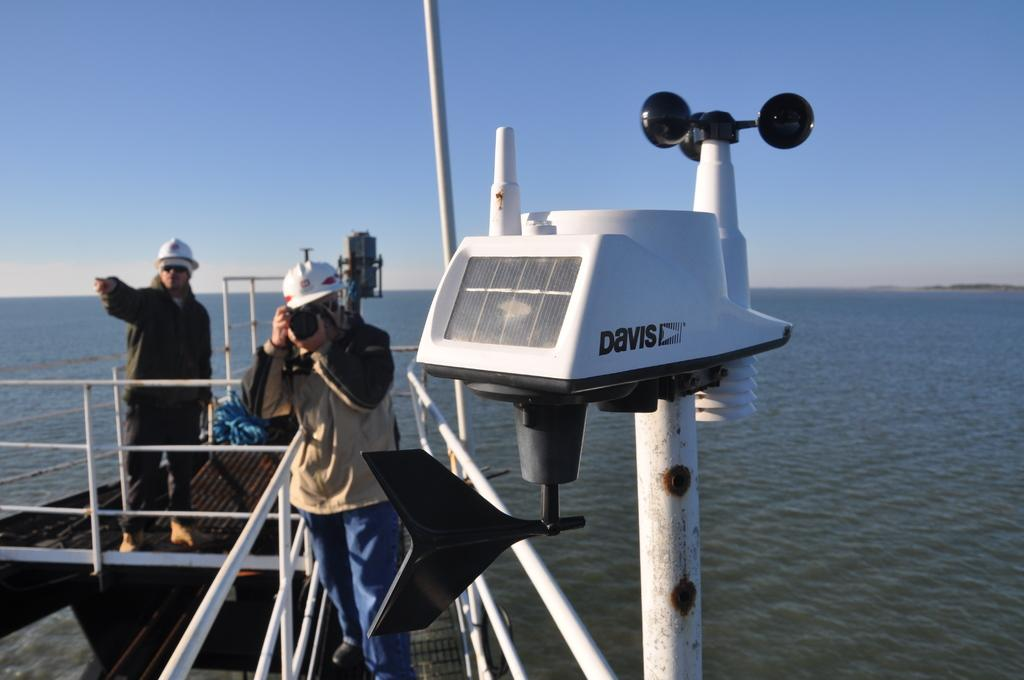<image>
Provide a brief description of the given image. A photographer takes a picture behind a Davis weather gathering instrument. 